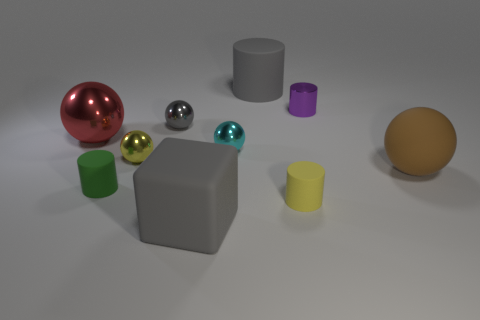Subtract all large spheres. How many spheres are left? 3 Subtract all cylinders. How many objects are left? 6 Subtract all yellow balls. How many balls are left? 4 Add 6 gray objects. How many gray objects exist? 9 Subtract 0 brown cylinders. How many objects are left? 10 Subtract 1 spheres. How many spheres are left? 4 Subtract all yellow cubes. Subtract all gray cylinders. How many cubes are left? 1 Subtract all small cylinders. Subtract all cyan objects. How many objects are left? 6 Add 8 tiny yellow balls. How many tiny yellow balls are left? 9 